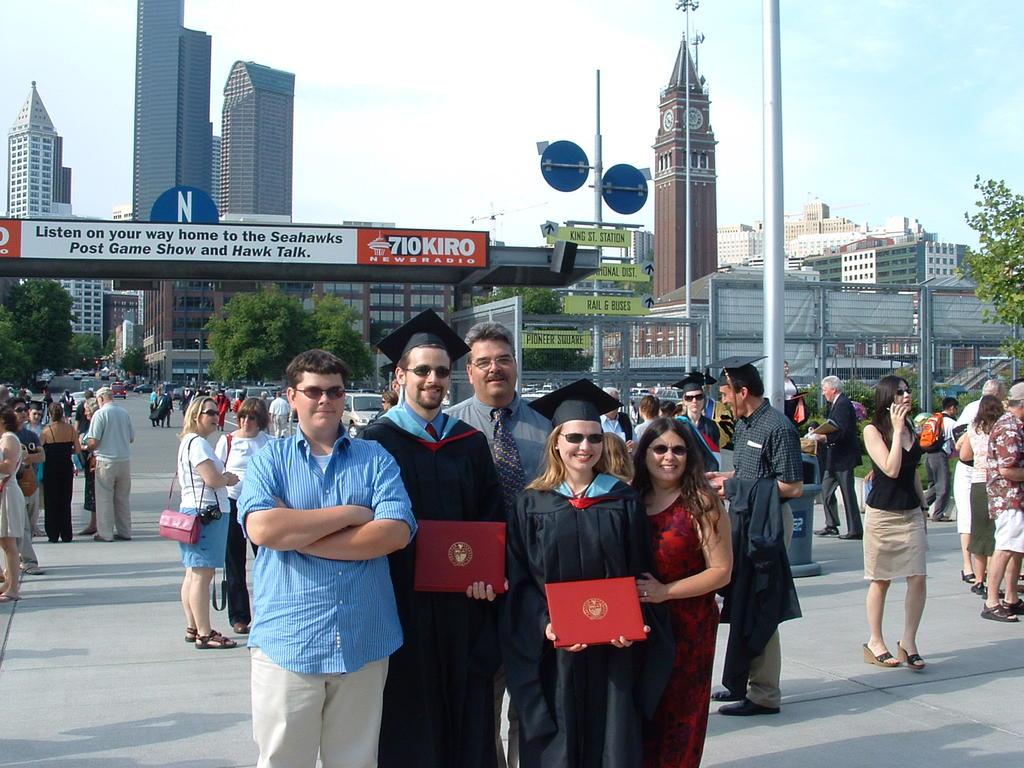What team is the post game show for?
Give a very brief answer. Seahawks. What is the radio station's channel number?
Your answer should be compact. 710. 